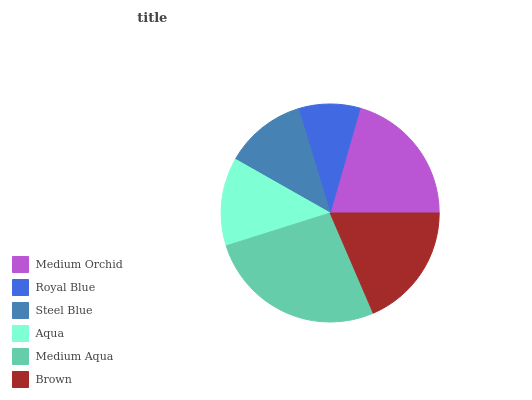Is Royal Blue the minimum?
Answer yes or no. Yes. Is Medium Aqua the maximum?
Answer yes or no. Yes. Is Steel Blue the minimum?
Answer yes or no. No. Is Steel Blue the maximum?
Answer yes or no. No. Is Steel Blue greater than Royal Blue?
Answer yes or no. Yes. Is Royal Blue less than Steel Blue?
Answer yes or no. Yes. Is Royal Blue greater than Steel Blue?
Answer yes or no. No. Is Steel Blue less than Royal Blue?
Answer yes or no. No. Is Brown the high median?
Answer yes or no. Yes. Is Aqua the low median?
Answer yes or no. Yes. Is Aqua the high median?
Answer yes or no. No. Is Steel Blue the low median?
Answer yes or no. No. 